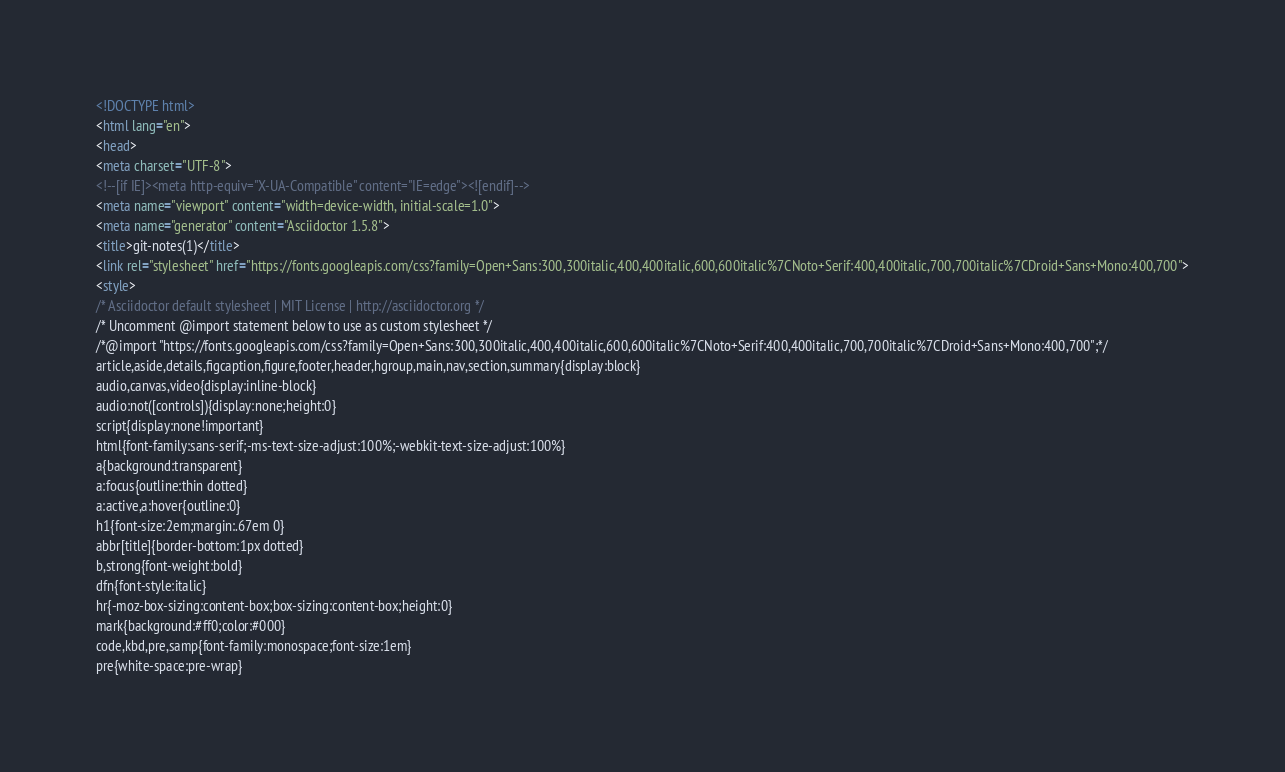<code> <loc_0><loc_0><loc_500><loc_500><_HTML_><!DOCTYPE html>
<html lang="en">
<head>
<meta charset="UTF-8">
<!--[if IE]><meta http-equiv="X-UA-Compatible" content="IE=edge"><![endif]-->
<meta name="viewport" content="width=device-width, initial-scale=1.0">
<meta name="generator" content="Asciidoctor 1.5.8">
<title>git-notes(1)</title>
<link rel="stylesheet" href="https://fonts.googleapis.com/css?family=Open+Sans:300,300italic,400,400italic,600,600italic%7CNoto+Serif:400,400italic,700,700italic%7CDroid+Sans+Mono:400,700">
<style>
/* Asciidoctor default stylesheet | MIT License | http://asciidoctor.org */
/* Uncomment @import statement below to use as custom stylesheet */
/*@import "https://fonts.googleapis.com/css?family=Open+Sans:300,300italic,400,400italic,600,600italic%7CNoto+Serif:400,400italic,700,700italic%7CDroid+Sans+Mono:400,700";*/
article,aside,details,figcaption,figure,footer,header,hgroup,main,nav,section,summary{display:block}
audio,canvas,video{display:inline-block}
audio:not([controls]){display:none;height:0}
script{display:none!important}
html{font-family:sans-serif;-ms-text-size-adjust:100%;-webkit-text-size-adjust:100%}
a{background:transparent}
a:focus{outline:thin dotted}
a:active,a:hover{outline:0}
h1{font-size:2em;margin:.67em 0}
abbr[title]{border-bottom:1px dotted}
b,strong{font-weight:bold}
dfn{font-style:italic}
hr{-moz-box-sizing:content-box;box-sizing:content-box;height:0}
mark{background:#ff0;color:#000}
code,kbd,pre,samp{font-family:monospace;font-size:1em}
pre{white-space:pre-wrap}</code> 